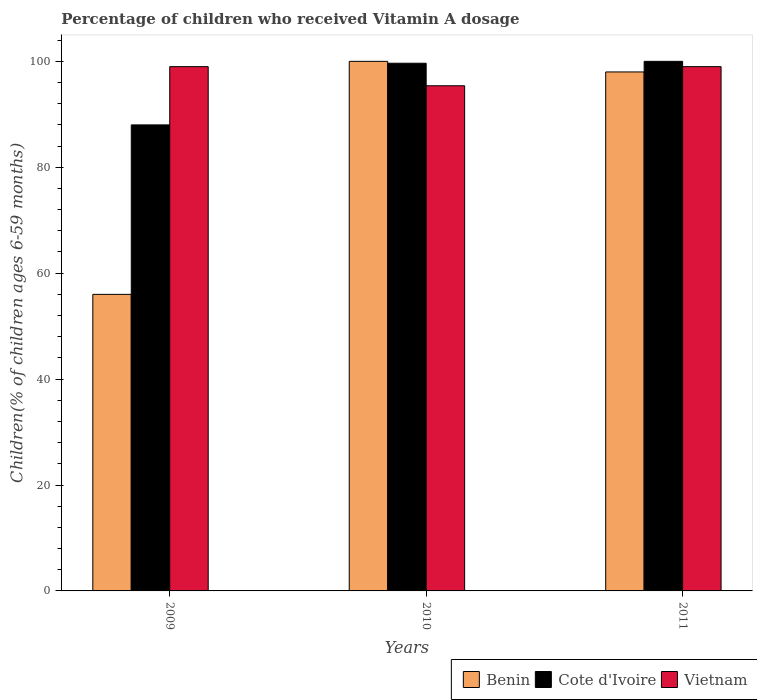How many different coloured bars are there?
Provide a short and direct response. 3. How many groups of bars are there?
Offer a very short reply. 3. How many bars are there on the 3rd tick from the left?
Offer a very short reply. 3. In how many cases, is the number of bars for a given year not equal to the number of legend labels?
Your answer should be very brief. 0. What is the percentage of children who received Vitamin A dosage in Vietnam in 2010?
Offer a terse response. 95.39. Across all years, what is the maximum percentage of children who received Vitamin A dosage in Vietnam?
Your answer should be very brief. 99. Across all years, what is the minimum percentage of children who received Vitamin A dosage in Benin?
Provide a succinct answer. 56. In which year was the percentage of children who received Vitamin A dosage in Cote d'Ivoire minimum?
Offer a terse response. 2009. What is the total percentage of children who received Vitamin A dosage in Cote d'Ivoire in the graph?
Your response must be concise. 287.64. What is the difference between the percentage of children who received Vitamin A dosage in Cote d'Ivoire in 2009 and that in 2010?
Provide a succinct answer. -11.64. What is the average percentage of children who received Vitamin A dosage in Benin per year?
Give a very brief answer. 84.67. In the year 2011, what is the difference between the percentage of children who received Vitamin A dosage in Vietnam and percentage of children who received Vitamin A dosage in Cote d'Ivoire?
Your answer should be compact. -1. In how many years, is the percentage of children who received Vitamin A dosage in Benin greater than 40 %?
Your answer should be very brief. 3. What is the ratio of the percentage of children who received Vitamin A dosage in Vietnam in 2010 to that in 2011?
Keep it short and to the point. 0.96. In how many years, is the percentage of children who received Vitamin A dosage in Vietnam greater than the average percentage of children who received Vitamin A dosage in Vietnam taken over all years?
Make the answer very short. 2. What does the 2nd bar from the left in 2009 represents?
Your response must be concise. Cote d'Ivoire. What does the 2nd bar from the right in 2011 represents?
Give a very brief answer. Cote d'Ivoire. How many bars are there?
Keep it short and to the point. 9. Does the graph contain any zero values?
Keep it short and to the point. No. Does the graph contain grids?
Your answer should be very brief. No. Where does the legend appear in the graph?
Your response must be concise. Bottom right. How many legend labels are there?
Your response must be concise. 3. How are the legend labels stacked?
Offer a very short reply. Horizontal. What is the title of the graph?
Make the answer very short. Percentage of children who received Vitamin A dosage. What is the label or title of the Y-axis?
Provide a succinct answer. Children(% of children ages 6-59 months). What is the Children(% of children ages 6-59 months) in Vietnam in 2009?
Your response must be concise. 99. What is the Children(% of children ages 6-59 months) in Cote d'Ivoire in 2010?
Provide a succinct answer. 99.64. What is the Children(% of children ages 6-59 months) in Vietnam in 2010?
Your answer should be very brief. 95.39. What is the Children(% of children ages 6-59 months) of Benin in 2011?
Your response must be concise. 98. What is the Children(% of children ages 6-59 months) of Vietnam in 2011?
Your response must be concise. 99. Across all years, what is the maximum Children(% of children ages 6-59 months) in Vietnam?
Your answer should be very brief. 99. Across all years, what is the minimum Children(% of children ages 6-59 months) in Benin?
Your answer should be very brief. 56. Across all years, what is the minimum Children(% of children ages 6-59 months) of Cote d'Ivoire?
Keep it short and to the point. 88. Across all years, what is the minimum Children(% of children ages 6-59 months) of Vietnam?
Your response must be concise. 95.39. What is the total Children(% of children ages 6-59 months) in Benin in the graph?
Make the answer very short. 254. What is the total Children(% of children ages 6-59 months) of Cote d'Ivoire in the graph?
Keep it short and to the point. 287.64. What is the total Children(% of children ages 6-59 months) in Vietnam in the graph?
Offer a terse response. 293.39. What is the difference between the Children(% of children ages 6-59 months) of Benin in 2009 and that in 2010?
Provide a short and direct response. -44. What is the difference between the Children(% of children ages 6-59 months) of Cote d'Ivoire in 2009 and that in 2010?
Offer a terse response. -11.64. What is the difference between the Children(% of children ages 6-59 months) of Vietnam in 2009 and that in 2010?
Your answer should be very brief. 3.61. What is the difference between the Children(% of children ages 6-59 months) of Benin in 2009 and that in 2011?
Your answer should be very brief. -42. What is the difference between the Children(% of children ages 6-59 months) of Vietnam in 2009 and that in 2011?
Your answer should be very brief. 0. What is the difference between the Children(% of children ages 6-59 months) of Cote d'Ivoire in 2010 and that in 2011?
Make the answer very short. -0.36. What is the difference between the Children(% of children ages 6-59 months) in Vietnam in 2010 and that in 2011?
Your answer should be compact. -3.61. What is the difference between the Children(% of children ages 6-59 months) in Benin in 2009 and the Children(% of children ages 6-59 months) in Cote d'Ivoire in 2010?
Give a very brief answer. -43.64. What is the difference between the Children(% of children ages 6-59 months) in Benin in 2009 and the Children(% of children ages 6-59 months) in Vietnam in 2010?
Offer a terse response. -39.39. What is the difference between the Children(% of children ages 6-59 months) of Cote d'Ivoire in 2009 and the Children(% of children ages 6-59 months) of Vietnam in 2010?
Provide a succinct answer. -7.39. What is the difference between the Children(% of children ages 6-59 months) in Benin in 2009 and the Children(% of children ages 6-59 months) in Cote d'Ivoire in 2011?
Your answer should be compact. -44. What is the difference between the Children(% of children ages 6-59 months) of Benin in 2009 and the Children(% of children ages 6-59 months) of Vietnam in 2011?
Offer a very short reply. -43. What is the difference between the Children(% of children ages 6-59 months) of Benin in 2010 and the Children(% of children ages 6-59 months) of Cote d'Ivoire in 2011?
Your answer should be very brief. 0. What is the difference between the Children(% of children ages 6-59 months) of Cote d'Ivoire in 2010 and the Children(% of children ages 6-59 months) of Vietnam in 2011?
Your answer should be compact. 0.64. What is the average Children(% of children ages 6-59 months) of Benin per year?
Offer a very short reply. 84.67. What is the average Children(% of children ages 6-59 months) in Cote d'Ivoire per year?
Give a very brief answer. 95.88. What is the average Children(% of children ages 6-59 months) of Vietnam per year?
Provide a succinct answer. 97.8. In the year 2009, what is the difference between the Children(% of children ages 6-59 months) in Benin and Children(% of children ages 6-59 months) in Cote d'Ivoire?
Make the answer very short. -32. In the year 2009, what is the difference between the Children(% of children ages 6-59 months) of Benin and Children(% of children ages 6-59 months) of Vietnam?
Give a very brief answer. -43. In the year 2010, what is the difference between the Children(% of children ages 6-59 months) in Benin and Children(% of children ages 6-59 months) in Cote d'Ivoire?
Your answer should be compact. 0.36. In the year 2010, what is the difference between the Children(% of children ages 6-59 months) of Benin and Children(% of children ages 6-59 months) of Vietnam?
Give a very brief answer. 4.61. In the year 2010, what is the difference between the Children(% of children ages 6-59 months) in Cote d'Ivoire and Children(% of children ages 6-59 months) in Vietnam?
Provide a short and direct response. 4.25. In the year 2011, what is the difference between the Children(% of children ages 6-59 months) of Benin and Children(% of children ages 6-59 months) of Cote d'Ivoire?
Provide a short and direct response. -2. In the year 2011, what is the difference between the Children(% of children ages 6-59 months) of Benin and Children(% of children ages 6-59 months) of Vietnam?
Make the answer very short. -1. In the year 2011, what is the difference between the Children(% of children ages 6-59 months) in Cote d'Ivoire and Children(% of children ages 6-59 months) in Vietnam?
Make the answer very short. 1. What is the ratio of the Children(% of children ages 6-59 months) in Benin in 2009 to that in 2010?
Make the answer very short. 0.56. What is the ratio of the Children(% of children ages 6-59 months) in Cote d'Ivoire in 2009 to that in 2010?
Provide a short and direct response. 0.88. What is the ratio of the Children(% of children ages 6-59 months) in Vietnam in 2009 to that in 2010?
Give a very brief answer. 1.04. What is the ratio of the Children(% of children ages 6-59 months) in Vietnam in 2009 to that in 2011?
Offer a terse response. 1. What is the ratio of the Children(% of children ages 6-59 months) in Benin in 2010 to that in 2011?
Your answer should be very brief. 1.02. What is the ratio of the Children(% of children ages 6-59 months) in Vietnam in 2010 to that in 2011?
Provide a short and direct response. 0.96. What is the difference between the highest and the second highest Children(% of children ages 6-59 months) of Cote d'Ivoire?
Make the answer very short. 0.36. What is the difference between the highest and the second highest Children(% of children ages 6-59 months) in Vietnam?
Offer a terse response. 0. What is the difference between the highest and the lowest Children(% of children ages 6-59 months) in Benin?
Give a very brief answer. 44. What is the difference between the highest and the lowest Children(% of children ages 6-59 months) in Cote d'Ivoire?
Provide a short and direct response. 12. What is the difference between the highest and the lowest Children(% of children ages 6-59 months) of Vietnam?
Offer a very short reply. 3.61. 